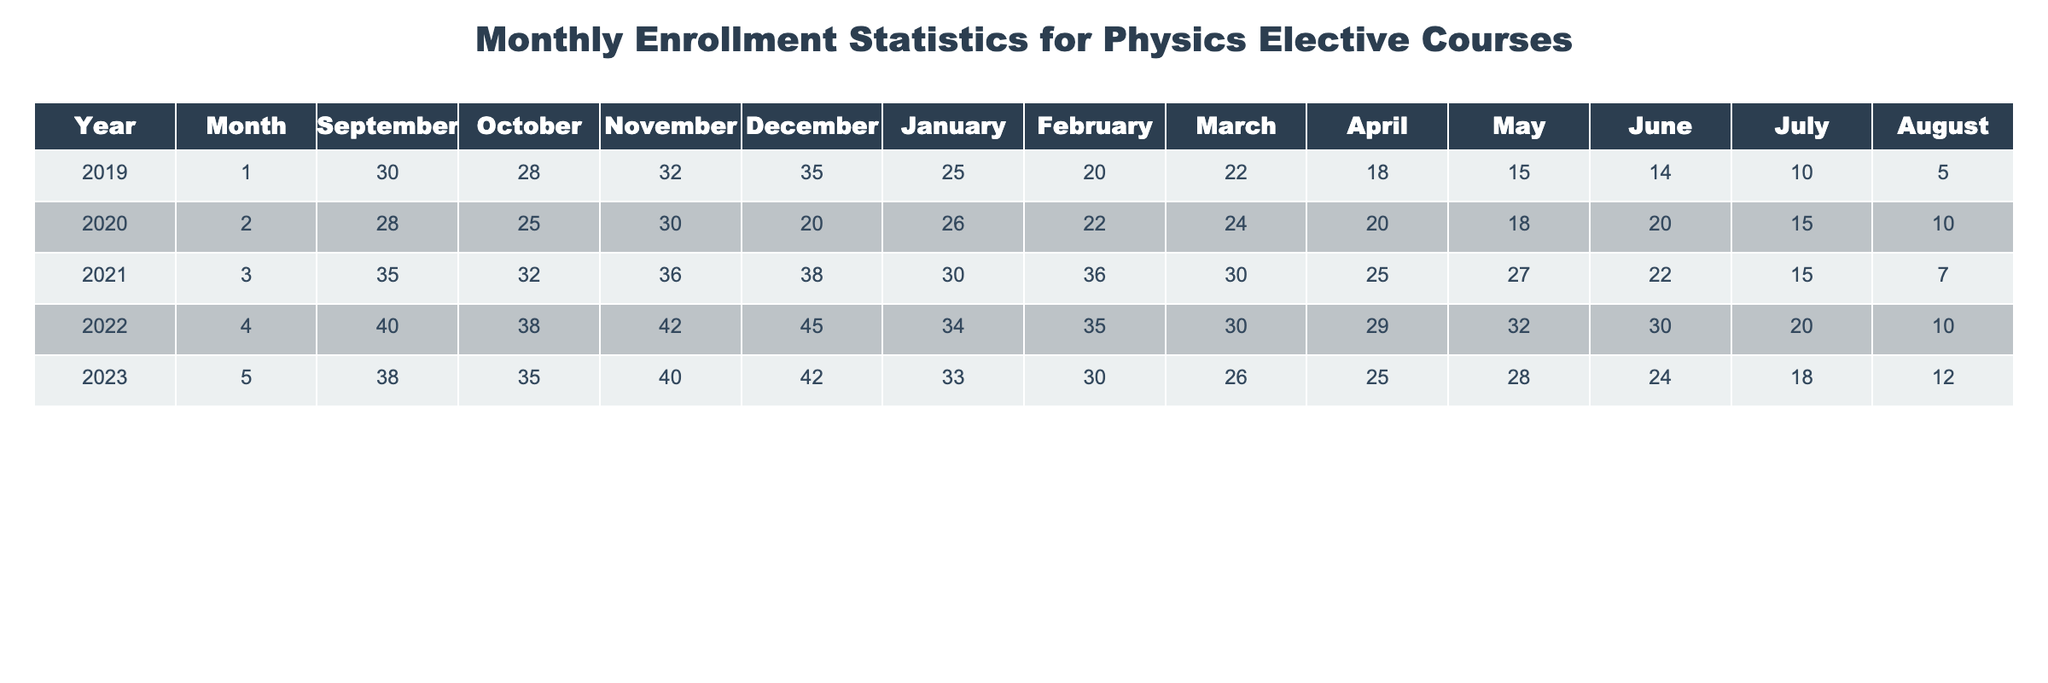What was the total enrollment in Physics elective courses in November 2021? The table shows the enrollment in November 2021 as 36. Thus, the total enrollment for that month is 36.
Answer: 36 What is the average enrollment in Physics elective courses for the year 2022? To find the average for 2022, we sum the monthly enrollments: 40 + 38 + 42 + 45 + 34 + 35 + 30 + 29 + 32 + 30 + 20 + 10 =  419. There are 12 months, so the average is 419/12 ≈ 34.92.
Answer: Approximately 34.92 Did enrollment increase in January from 2019 to 2023? In January 2019, the enrollment was 25, and in January 2023, it was 33. Since 33 is greater than 25, enrollment increased.
Answer: Yes What was the maximum enrollment recorded in a single month over the five years? Looking at the monthly enrollments, the maximum value is 45, which occurred in December 2022.
Answer: 45 By how much did the enrollment in Physics elective courses decrease from December 2020 to December 2022? In December 2020, enrollment was 20, and in December 2022, it was 45. The decrease calculation: 20 - 45 = -25 indicates an increase, since the difference is negative, there was an increase in enrollment.
Answer: An increase of 25 What month had the lowest total enrollment across all five years and what was the value? By checking the table, we find that the lowest value occurs in August 2019 with an enrollment of 5.
Answer: 5 in August 2019 In which year did Physics enrollment in June exceed 30 students? By examining the table, June 2021, 2022, and 2023 have enrollment of 22, 30, and 24 respectively. Therefore, the answer is 2022 as that is the only year in June to exceed 30 students.
Answer: 2022 What was the percentage decrease in enrollment from August 2019 to August 2023? Enrollment in August 2019 was 5, and in August 2023 it was 12. The decrease calculation: (12 - 5) / 5 * 100 = 140%. So there's actually an increase by 140%.
Answer: An increase of 140% Which month in 2021 had the highest enrollment and what was the number? Checking each month in 2021, March had the highest enrollment at 36.
Answer: 36 in March 2021 How many months in the five years saw an enrollment of 30 or more students? Counting the months from the table, we find there are 15 occurrences of months with enrollment at or above 30.
Answer: 15 